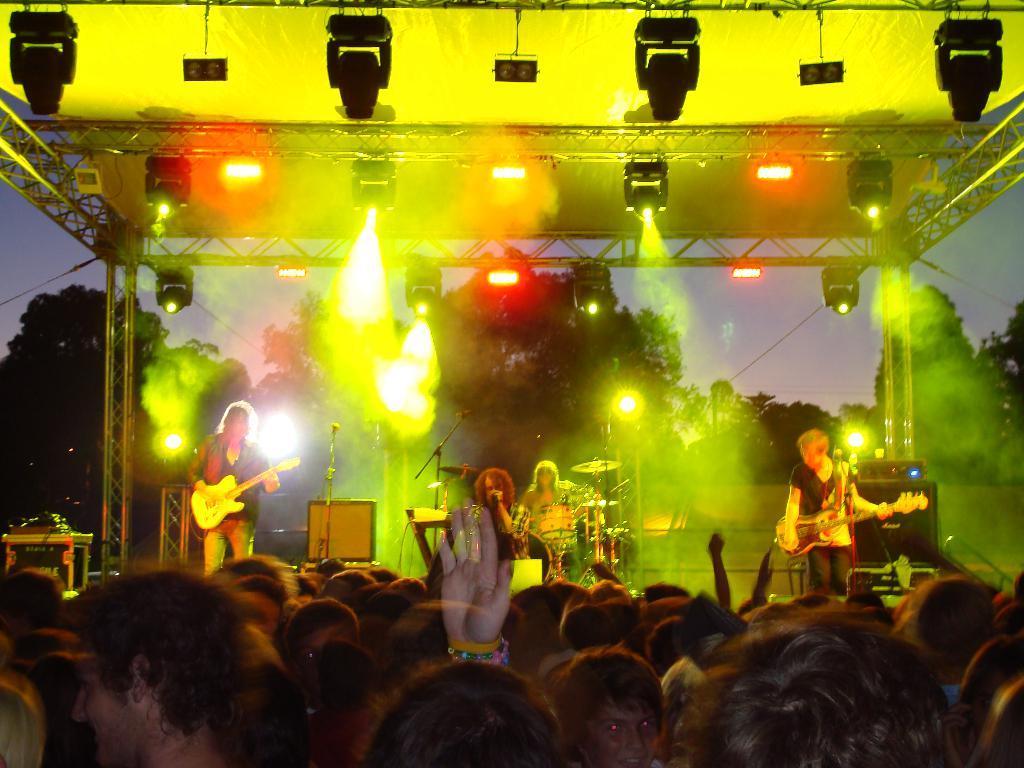In one or two sentences, can you explain what this image depicts? In this image there are few people playing musical instruments on the stage, there are few lights attached at the top of the stage, there are few people and few trees. 